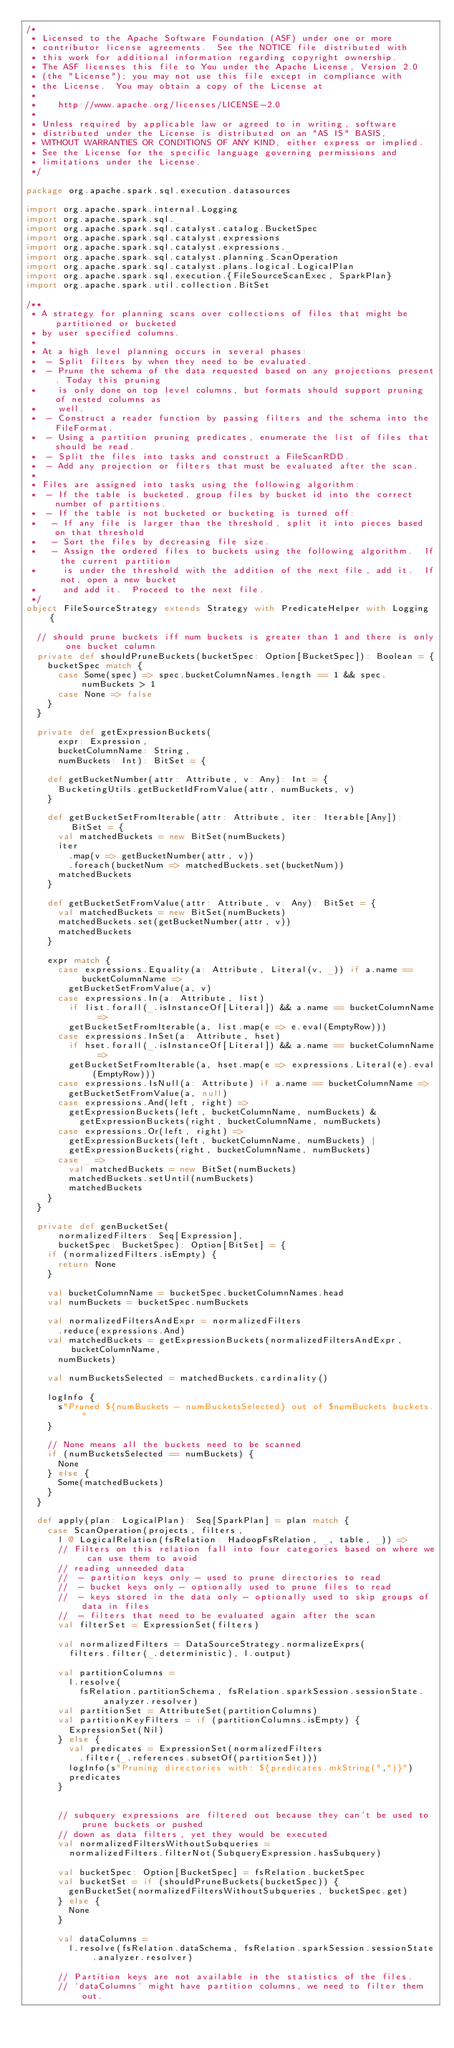Convert code to text. <code><loc_0><loc_0><loc_500><loc_500><_Scala_>/*
 * Licensed to the Apache Software Foundation (ASF) under one or more
 * contributor license agreements.  See the NOTICE file distributed with
 * this work for additional information regarding copyright ownership.
 * The ASF licenses this file to You under the Apache License, Version 2.0
 * (the "License"); you may not use this file except in compliance with
 * the License.  You may obtain a copy of the License at
 *
 *    http://www.apache.org/licenses/LICENSE-2.0
 *
 * Unless required by applicable law or agreed to in writing, software
 * distributed under the License is distributed on an "AS IS" BASIS,
 * WITHOUT WARRANTIES OR CONDITIONS OF ANY KIND, either express or implied.
 * See the License for the specific language governing permissions and
 * limitations under the License.
 */

package org.apache.spark.sql.execution.datasources

import org.apache.spark.internal.Logging
import org.apache.spark.sql._
import org.apache.spark.sql.catalyst.catalog.BucketSpec
import org.apache.spark.sql.catalyst.expressions
import org.apache.spark.sql.catalyst.expressions._
import org.apache.spark.sql.catalyst.planning.ScanOperation
import org.apache.spark.sql.catalyst.plans.logical.LogicalPlan
import org.apache.spark.sql.execution.{FileSourceScanExec, SparkPlan}
import org.apache.spark.util.collection.BitSet

/**
 * A strategy for planning scans over collections of files that might be partitioned or bucketed
 * by user specified columns.
 *
 * At a high level planning occurs in several phases:
 *  - Split filters by when they need to be evaluated.
 *  - Prune the schema of the data requested based on any projections present. Today this pruning
 *    is only done on top level columns, but formats should support pruning of nested columns as
 *    well.
 *  - Construct a reader function by passing filters and the schema into the FileFormat.
 *  - Using a partition pruning predicates, enumerate the list of files that should be read.
 *  - Split the files into tasks and construct a FileScanRDD.
 *  - Add any projection or filters that must be evaluated after the scan.
 *
 * Files are assigned into tasks using the following algorithm:
 *  - If the table is bucketed, group files by bucket id into the correct number of partitions.
 *  - If the table is not bucketed or bucketing is turned off:
 *   - If any file is larger than the threshold, split it into pieces based on that threshold
 *   - Sort the files by decreasing file size.
 *   - Assign the ordered files to buckets using the following algorithm.  If the current partition
 *     is under the threshold with the addition of the next file, add it.  If not, open a new bucket
 *     and add it.  Proceed to the next file.
 */
object FileSourceStrategy extends Strategy with PredicateHelper with Logging {

  // should prune buckets iff num buckets is greater than 1 and there is only one bucket column
  private def shouldPruneBuckets(bucketSpec: Option[BucketSpec]): Boolean = {
    bucketSpec match {
      case Some(spec) => spec.bucketColumnNames.length == 1 && spec.numBuckets > 1
      case None => false
    }
  }

  private def getExpressionBuckets(
      expr: Expression,
      bucketColumnName: String,
      numBuckets: Int): BitSet = {

    def getBucketNumber(attr: Attribute, v: Any): Int = {
      BucketingUtils.getBucketIdFromValue(attr, numBuckets, v)
    }

    def getBucketSetFromIterable(attr: Attribute, iter: Iterable[Any]): BitSet = {
      val matchedBuckets = new BitSet(numBuckets)
      iter
        .map(v => getBucketNumber(attr, v))
        .foreach(bucketNum => matchedBuckets.set(bucketNum))
      matchedBuckets
    }

    def getBucketSetFromValue(attr: Attribute, v: Any): BitSet = {
      val matchedBuckets = new BitSet(numBuckets)
      matchedBuckets.set(getBucketNumber(attr, v))
      matchedBuckets
    }

    expr match {
      case expressions.Equality(a: Attribute, Literal(v, _)) if a.name == bucketColumnName =>
        getBucketSetFromValue(a, v)
      case expressions.In(a: Attribute, list)
        if list.forall(_.isInstanceOf[Literal]) && a.name == bucketColumnName =>
        getBucketSetFromIterable(a, list.map(e => e.eval(EmptyRow)))
      case expressions.InSet(a: Attribute, hset)
        if hset.forall(_.isInstanceOf[Literal]) && a.name == bucketColumnName =>
        getBucketSetFromIterable(a, hset.map(e => expressions.Literal(e).eval(EmptyRow)))
      case expressions.IsNull(a: Attribute) if a.name == bucketColumnName =>
        getBucketSetFromValue(a, null)
      case expressions.And(left, right) =>
        getExpressionBuckets(left, bucketColumnName, numBuckets) &
          getExpressionBuckets(right, bucketColumnName, numBuckets)
      case expressions.Or(left, right) =>
        getExpressionBuckets(left, bucketColumnName, numBuckets) |
        getExpressionBuckets(right, bucketColumnName, numBuckets)
      case _ =>
        val matchedBuckets = new BitSet(numBuckets)
        matchedBuckets.setUntil(numBuckets)
        matchedBuckets
    }
  }

  private def genBucketSet(
      normalizedFilters: Seq[Expression],
      bucketSpec: BucketSpec): Option[BitSet] = {
    if (normalizedFilters.isEmpty) {
      return None
    }

    val bucketColumnName = bucketSpec.bucketColumnNames.head
    val numBuckets = bucketSpec.numBuckets

    val normalizedFiltersAndExpr = normalizedFilters
      .reduce(expressions.And)
    val matchedBuckets = getExpressionBuckets(normalizedFiltersAndExpr, bucketColumnName,
      numBuckets)

    val numBucketsSelected = matchedBuckets.cardinality()

    logInfo {
      s"Pruned ${numBuckets - numBucketsSelected} out of $numBuckets buckets."
    }

    // None means all the buckets need to be scanned
    if (numBucketsSelected == numBuckets) {
      None
    } else {
      Some(matchedBuckets)
    }
  }

  def apply(plan: LogicalPlan): Seq[SparkPlan] = plan match {
    case ScanOperation(projects, filters,
      l @ LogicalRelation(fsRelation: HadoopFsRelation, _, table, _)) =>
      // Filters on this relation fall into four categories based on where we can use them to avoid
      // reading unneeded data:
      //  - partition keys only - used to prune directories to read
      //  - bucket keys only - optionally used to prune files to read
      //  - keys stored in the data only - optionally used to skip groups of data in files
      //  - filters that need to be evaluated again after the scan
      val filterSet = ExpressionSet(filters)

      val normalizedFilters = DataSourceStrategy.normalizeExprs(
        filters.filter(_.deterministic), l.output)

      val partitionColumns =
        l.resolve(
          fsRelation.partitionSchema, fsRelation.sparkSession.sessionState.analyzer.resolver)
      val partitionSet = AttributeSet(partitionColumns)
      val partitionKeyFilters = if (partitionColumns.isEmpty) {
        ExpressionSet(Nil)
      } else {
        val predicates = ExpressionSet(normalizedFilters
          .filter(_.references.subsetOf(partitionSet)))
        logInfo(s"Pruning directories with: ${predicates.mkString(",")}")
        predicates
      }


      // subquery expressions are filtered out because they can't be used to prune buckets or pushed
      // down as data filters, yet they would be executed
      val normalizedFiltersWithoutSubqueries =
        normalizedFilters.filterNot(SubqueryExpression.hasSubquery)

      val bucketSpec: Option[BucketSpec] = fsRelation.bucketSpec
      val bucketSet = if (shouldPruneBuckets(bucketSpec)) {
        genBucketSet(normalizedFiltersWithoutSubqueries, bucketSpec.get)
      } else {
        None
      }

      val dataColumns =
        l.resolve(fsRelation.dataSchema, fsRelation.sparkSession.sessionState.analyzer.resolver)

      // Partition keys are not available in the statistics of the files.
      // `dataColumns` might have partition columns, we need to filter them out.</code> 